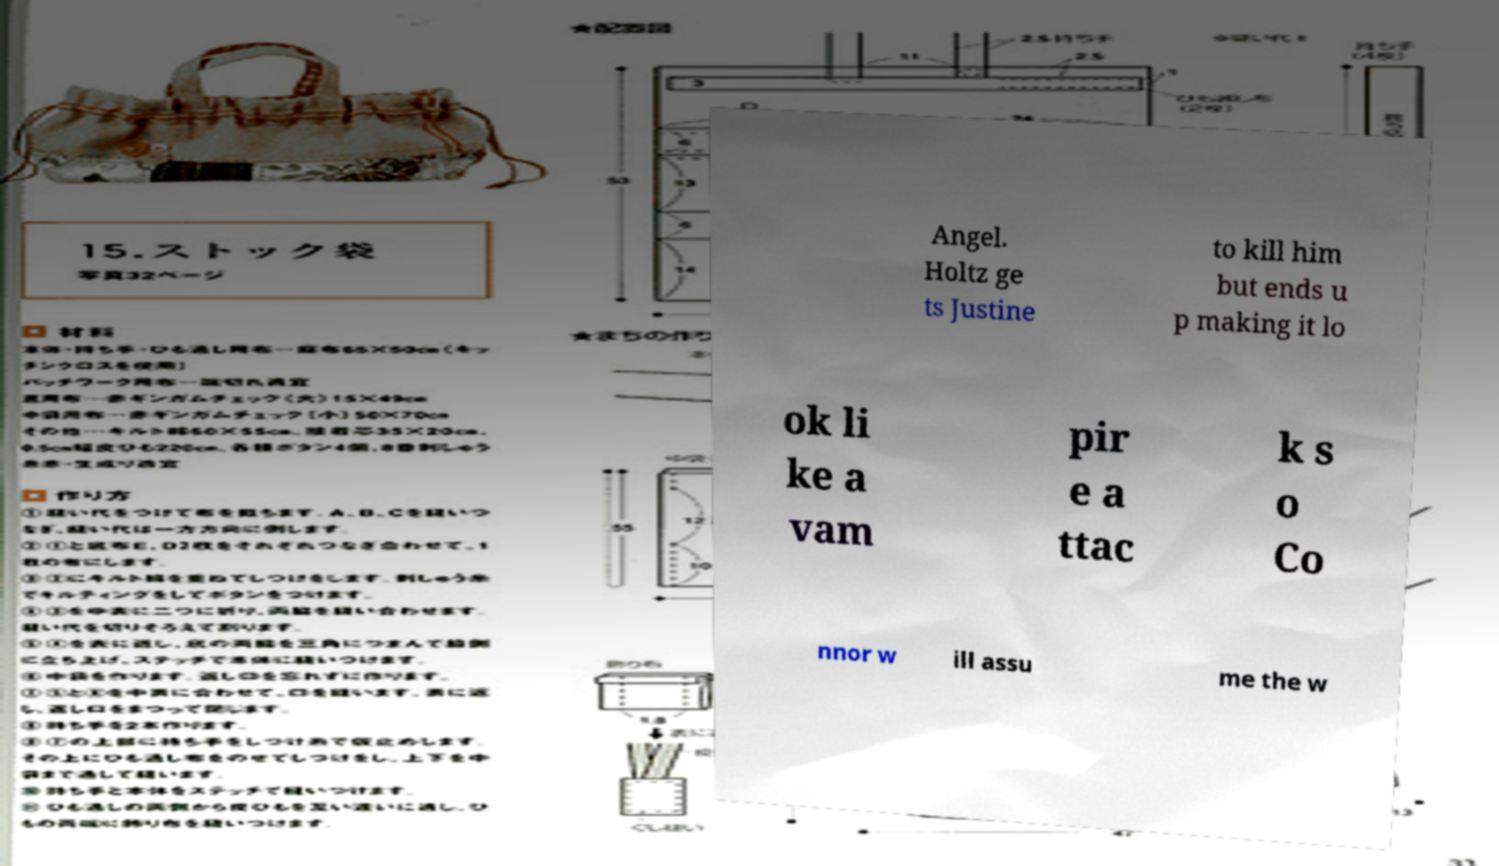For documentation purposes, I need the text within this image transcribed. Could you provide that? Angel. Holtz ge ts Justine to kill him but ends u p making it lo ok li ke a vam pir e a ttac k s o Co nnor w ill assu me the w 